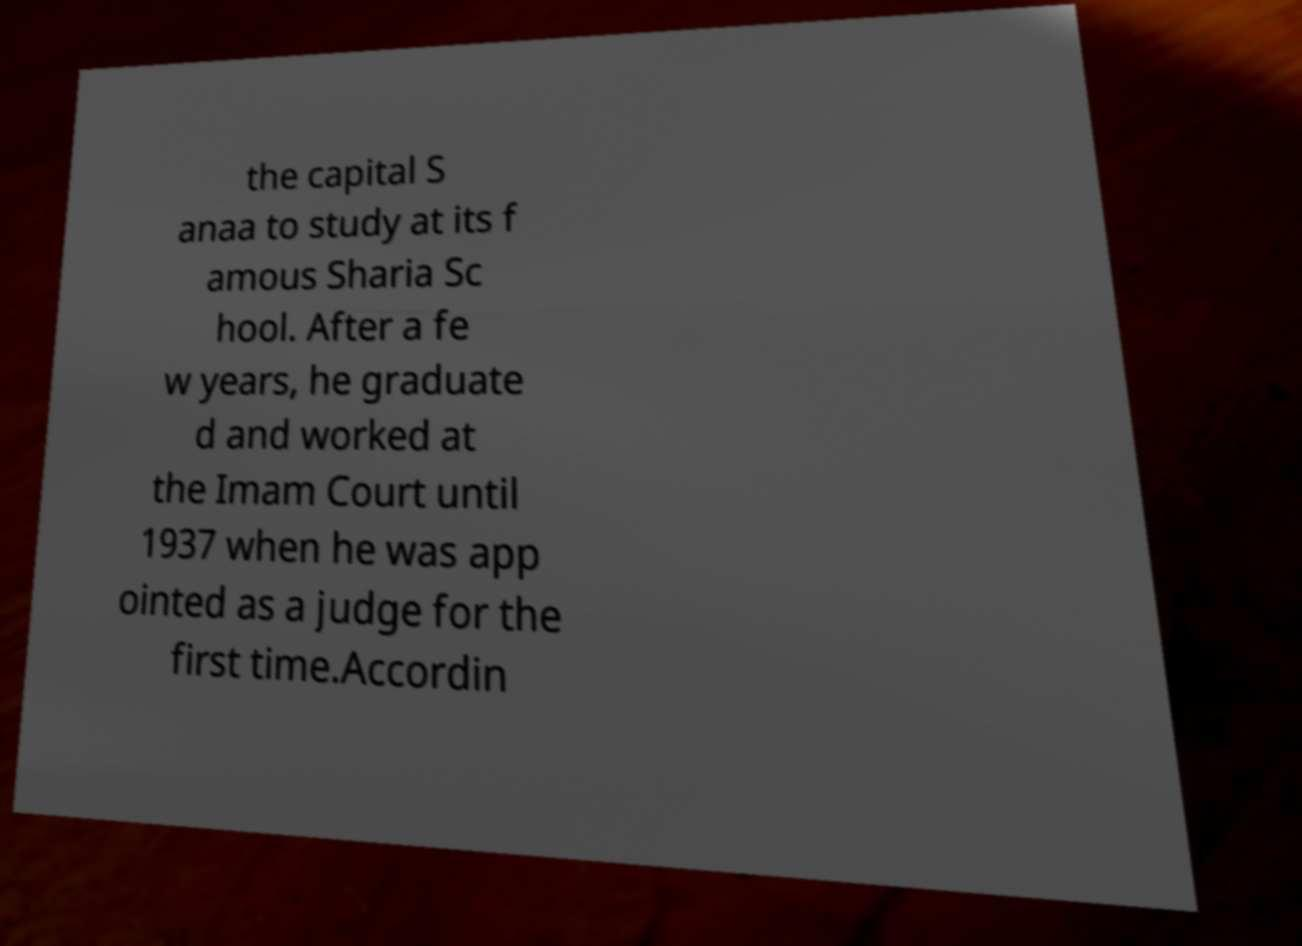Can you read and provide the text displayed in the image?This photo seems to have some interesting text. Can you extract and type it out for me? the capital S anaa to study at its f amous Sharia Sc hool. After a fe w years, he graduate d and worked at the Imam Court until 1937 when he was app ointed as a judge for the first time.Accordin 